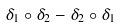Convert formula to latex. <formula><loc_0><loc_0><loc_500><loc_500>\delta _ { 1 } \circ \delta _ { 2 } - \delta _ { 2 } \circ \delta _ { 1 }</formula> 